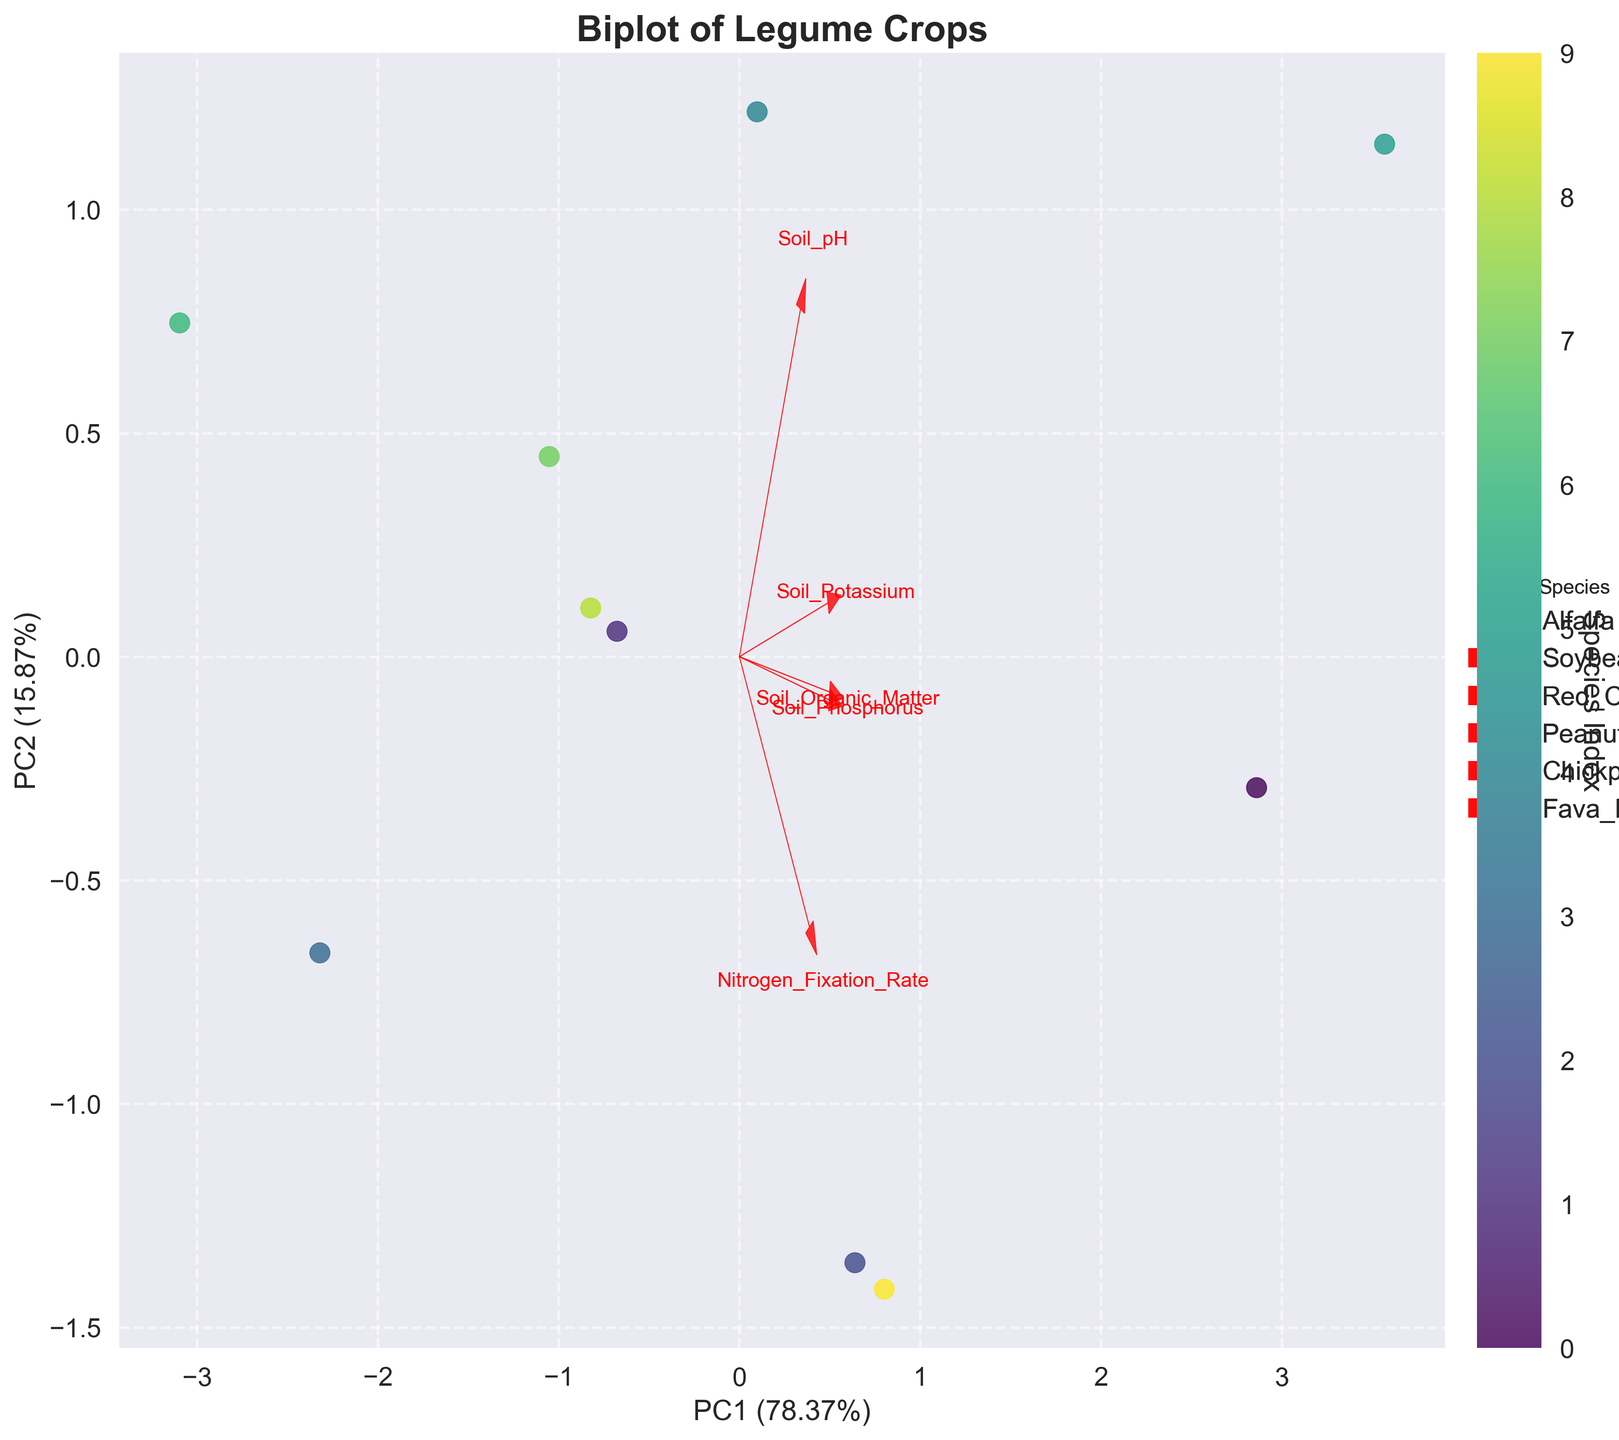what is the title of the plot? The title of the plot is generally displayed prominently at the top of the figure. This helps the viewer understand the overall topic of the visualization.
Answer: Biplot of Legume Crops what does the x-axis represent? The x-axis label usually tells us what data is represented along this axis. In this case, it shows the first principal component (PC1) and its explained variance ratio.
Answer: PC1 what color indicates the species? The biplot uses a color gradient to differentiate between species, as indicated by the color bar labeled "Species Index".
Answer: A color gradient which species has the highest nitrogen fixation rate and where is it located on the plot? To answer this, you need to identify the species with the highest Nitrogen_Fixation_Rate, which is Alfalfa. The position of Alfalfa's marker on the biplot will indicate its location.
Answer: Alfalfa at the top right quadrant how do soil pH and soil organic matter contribute to the first and second principal components? Look at the direction and length of the arrows representing soil pH and soil organic matter. Compare their contributions to both axes by noticing the projections.
Answer: Soil pH has a stronger contribution to PC1, while soil organic matter contributes more to PC2 which species appear closest to each other on the biplot? By visually inspecting the plot, identify species that are clustered near each other in the PCA-transformed space.
Answer: Soybean and Chickpea is higher soil potassium related to higher or lower nitrogen fixation rates? The relationship can be inferred by examining the vectors of soil potassium and nitrogen fixation rate on the biplot. Look at their directions and angles relative to each other.
Answer: Generally related to higher nitrogen fixation rates which principal component explains more variance in the dataset? The labels of the x-axis and y-axis indicate the explained variance ratio for the corresponding principal components. Compare these values.
Answer: PC1 what vector has the largest arrow and what does that imply? Identify the arrow with the longest length among the feature vectors. The length indicates the magnitude of the variable's contribution to the principal components.
Answer: Nitrogen Fixation Rate, implying it has the greatest influence 